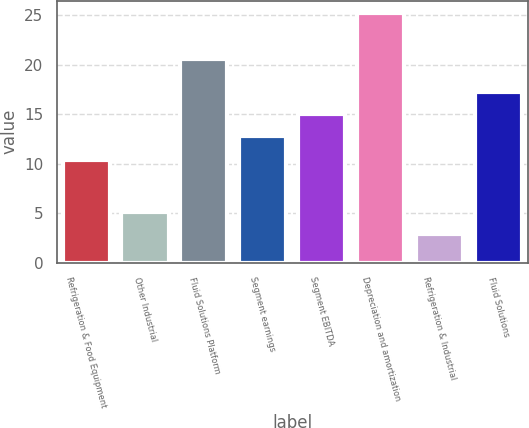Convert chart. <chart><loc_0><loc_0><loc_500><loc_500><bar_chart><fcel>Refrigeration & Food Equipment<fcel>Other Industrial<fcel>Fluid Solutions Platform<fcel>Segment earnings<fcel>Segment EBITDA<fcel>Depreciation and amortization<fcel>Refrigeration & Industrial<fcel>Fluid Solutions<nl><fcel>10.4<fcel>5.13<fcel>20.6<fcel>12.8<fcel>15.03<fcel>25.2<fcel>2.9<fcel>17.26<nl></chart> 